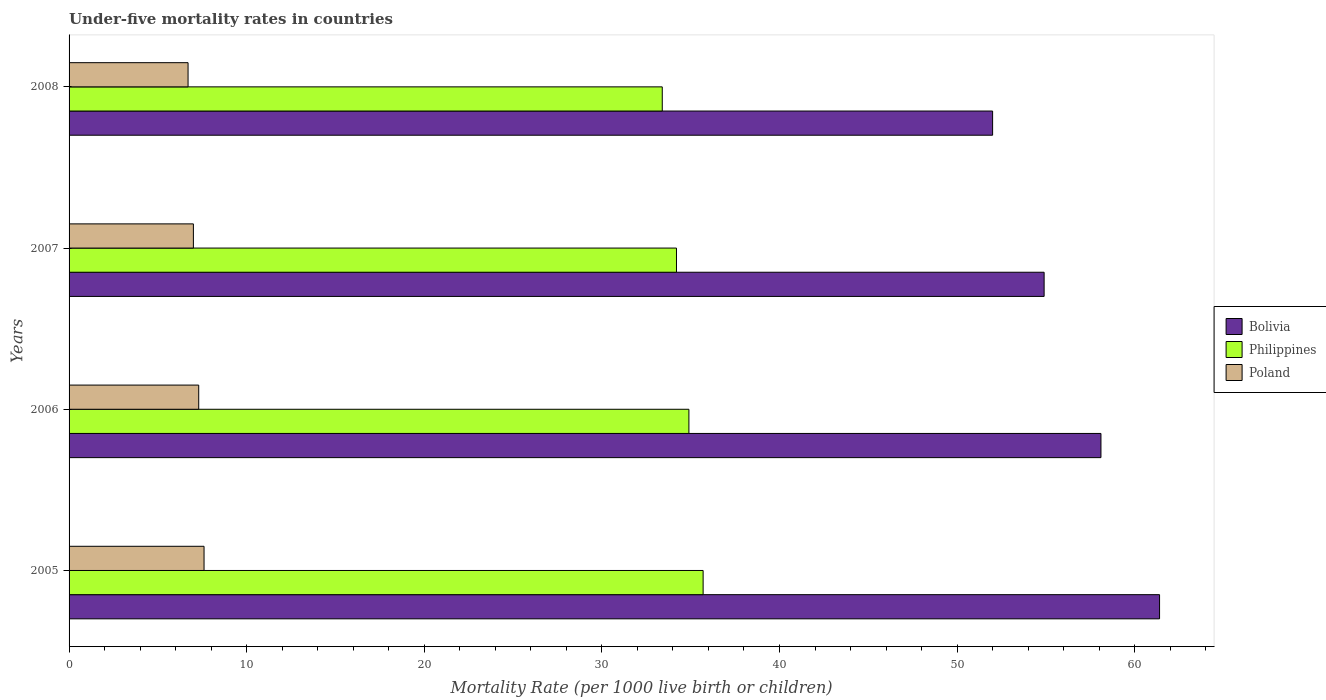In how many cases, is the number of bars for a given year not equal to the number of legend labels?
Keep it short and to the point. 0. Across all years, what is the maximum under-five mortality rate in Philippines?
Your answer should be compact. 35.7. Across all years, what is the minimum under-five mortality rate in Poland?
Your answer should be compact. 6.7. What is the total under-five mortality rate in Philippines in the graph?
Provide a succinct answer. 138.2. What is the difference between the under-five mortality rate in Bolivia in 2005 and that in 2006?
Provide a short and direct response. 3.3. What is the difference between the under-five mortality rate in Bolivia in 2006 and the under-five mortality rate in Poland in 2005?
Keep it short and to the point. 50.5. What is the average under-five mortality rate in Poland per year?
Offer a terse response. 7.15. In the year 2005, what is the difference between the under-five mortality rate in Philippines and under-five mortality rate in Bolivia?
Give a very brief answer. -25.7. In how many years, is the under-five mortality rate in Bolivia greater than 54 ?
Your answer should be very brief. 3. What is the ratio of the under-five mortality rate in Bolivia in 2007 to that in 2008?
Offer a very short reply. 1.06. Is the under-five mortality rate in Philippines in 2005 less than that in 2006?
Offer a very short reply. No. What is the difference between the highest and the second highest under-five mortality rate in Philippines?
Keep it short and to the point. 0.8. What is the difference between the highest and the lowest under-five mortality rate in Bolivia?
Provide a succinct answer. 9.4. Is the sum of the under-five mortality rate in Philippines in 2007 and 2008 greater than the maximum under-five mortality rate in Bolivia across all years?
Ensure brevity in your answer.  Yes. What does the 2nd bar from the bottom in 2007 represents?
Your answer should be compact. Philippines. How many bars are there?
Offer a terse response. 12. Are all the bars in the graph horizontal?
Offer a very short reply. Yes. How many years are there in the graph?
Offer a terse response. 4. What is the difference between two consecutive major ticks on the X-axis?
Make the answer very short. 10. How are the legend labels stacked?
Provide a succinct answer. Vertical. What is the title of the graph?
Provide a short and direct response. Under-five mortality rates in countries. What is the label or title of the X-axis?
Offer a very short reply. Mortality Rate (per 1000 live birth or children). What is the label or title of the Y-axis?
Provide a succinct answer. Years. What is the Mortality Rate (per 1000 live birth or children) in Bolivia in 2005?
Ensure brevity in your answer.  61.4. What is the Mortality Rate (per 1000 live birth or children) of Philippines in 2005?
Make the answer very short. 35.7. What is the Mortality Rate (per 1000 live birth or children) in Bolivia in 2006?
Ensure brevity in your answer.  58.1. What is the Mortality Rate (per 1000 live birth or children) in Philippines in 2006?
Give a very brief answer. 34.9. What is the Mortality Rate (per 1000 live birth or children) of Poland in 2006?
Your answer should be compact. 7.3. What is the Mortality Rate (per 1000 live birth or children) in Bolivia in 2007?
Your answer should be compact. 54.9. What is the Mortality Rate (per 1000 live birth or children) in Philippines in 2007?
Make the answer very short. 34.2. What is the Mortality Rate (per 1000 live birth or children) in Poland in 2007?
Provide a short and direct response. 7. What is the Mortality Rate (per 1000 live birth or children) of Bolivia in 2008?
Ensure brevity in your answer.  52. What is the Mortality Rate (per 1000 live birth or children) of Philippines in 2008?
Ensure brevity in your answer.  33.4. What is the Mortality Rate (per 1000 live birth or children) of Poland in 2008?
Make the answer very short. 6.7. Across all years, what is the maximum Mortality Rate (per 1000 live birth or children) in Bolivia?
Offer a very short reply. 61.4. Across all years, what is the maximum Mortality Rate (per 1000 live birth or children) in Philippines?
Ensure brevity in your answer.  35.7. Across all years, what is the maximum Mortality Rate (per 1000 live birth or children) in Poland?
Offer a terse response. 7.6. Across all years, what is the minimum Mortality Rate (per 1000 live birth or children) of Philippines?
Provide a succinct answer. 33.4. Across all years, what is the minimum Mortality Rate (per 1000 live birth or children) of Poland?
Your answer should be compact. 6.7. What is the total Mortality Rate (per 1000 live birth or children) in Bolivia in the graph?
Offer a very short reply. 226.4. What is the total Mortality Rate (per 1000 live birth or children) in Philippines in the graph?
Your answer should be very brief. 138.2. What is the total Mortality Rate (per 1000 live birth or children) of Poland in the graph?
Keep it short and to the point. 28.6. What is the difference between the Mortality Rate (per 1000 live birth or children) of Bolivia in 2005 and that in 2006?
Offer a very short reply. 3.3. What is the difference between the Mortality Rate (per 1000 live birth or children) of Philippines in 2005 and that in 2006?
Offer a very short reply. 0.8. What is the difference between the Mortality Rate (per 1000 live birth or children) of Bolivia in 2005 and that in 2007?
Provide a short and direct response. 6.5. What is the difference between the Mortality Rate (per 1000 live birth or children) of Bolivia in 2006 and that in 2007?
Offer a very short reply. 3.2. What is the difference between the Mortality Rate (per 1000 live birth or children) in Poland in 2006 and that in 2007?
Offer a very short reply. 0.3. What is the difference between the Mortality Rate (per 1000 live birth or children) of Bolivia in 2006 and that in 2008?
Your answer should be very brief. 6.1. What is the difference between the Mortality Rate (per 1000 live birth or children) of Philippines in 2007 and that in 2008?
Your answer should be compact. 0.8. What is the difference between the Mortality Rate (per 1000 live birth or children) in Bolivia in 2005 and the Mortality Rate (per 1000 live birth or children) in Poland in 2006?
Provide a succinct answer. 54.1. What is the difference between the Mortality Rate (per 1000 live birth or children) of Philippines in 2005 and the Mortality Rate (per 1000 live birth or children) of Poland in 2006?
Provide a succinct answer. 28.4. What is the difference between the Mortality Rate (per 1000 live birth or children) in Bolivia in 2005 and the Mortality Rate (per 1000 live birth or children) in Philippines in 2007?
Ensure brevity in your answer.  27.2. What is the difference between the Mortality Rate (per 1000 live birth or children) of Bolivia in 2005 and the Mortality Rate (per 1000 live birth or children) of Poland in 2007?
Provide a succinct answer. 54.4. What is the difference between the Mortality Rate (per 1000 live birth or children) of Philippines in 2005 and the Mortality Rate (per 1000 live birth or children) of Poland in 2007?
Provide a succinct answer. 28.7. What is the difference between the Mortality Rate (per 1000 live birth or children) in Bolivia in 2005 and the Mortality Rate (per 1000 live birth or children) in Philippines in 2008?
Make the answer very short. 28. What is the difference between the Mortality Rate (per 1000 live birth or children) in Bolivia in 2005 and the Mortality Rate (per 1000 live birth or children) in Poland in 2008?
Ensure brevity in your answer.  54.7. What is the difference between the Mortality Rate (per 1000 live birth or children) in Bolivia in 2006 and the Mortality Rate (per 1000 live birth or children) in Philippines in 2007?
Give a very brief answer. 23.9. What is the difference between the Mortality Rate (per 1000 live birth or children) in Bolivia in 2006 and the Mortality Rate (per 1000 live birth or children) in Poland in 2007?
Your answer should be very brief. 51.1. What is the difference between the Mortality Rate (per 1000 live birth or children) of Philippines in 2006 and the Mortality Rate (per 1000 live birth or children) of Poland in 2007?
Provide a short and direct response. 27.9. What is the difference between the Mortality Rate (per 1000 live birth or children) of Bolivia in 2006 and the Mortality Rate (per 1000 live birth or children) of Philippines in 2008?
Ensure brevity in your answer.  24.7. What is the difference between the Mortality Rate (per 1000 live birth or children) in Bolivia in 2006 and the Mortality Rate (per 1000 live birth or children) in Poland in 2008?
Ensure brevity in your answer.  51.4. What is the difference between the Mortality Rate (per 1000 live birth or children) in Philippines in 2006 and the Mortality Rate (per 1000 live birth or children) in Poland in 2008?
Offer a very short reply. 28.2. What is the difference between the Mortality Rate (per 1000 live birth or children) of Bolivia in 2007 and the Mortality Rate (per 1000 live birth or children) of Poland in 2008?
Provide a short and direct response. 48.2. What is the difference between the Mortality Rate (per 1000 live birth or children) of Philippines in 2007 and the Mortality Rate (per 1000 live birth or children) of Poland in 2008?
Offer a very short reply. 27.5. What is the average Mortality Rate (per 1000 live birth or children) of Bolivia per year?
Your answer should be very brief. 56.6. What is the average Mortality Rate (per 1000 live birth or children) of Philippines per year?
Your answer should be compact. 34.55. What is the average Mortality Rate (per 1000 live birth or children) of Poland per year?
Ensure brevity in your answer.  7.15. In the year 2005, what is the difference between the Mortality Rate (per 1000 live birth or children) of Bolivia and Mortality Rate (per 1000 live birth or children) of Philippines?
Offer a very short reply. 25.7. In the year 2005, what is the difference between the Mortality Rate (per 1000 live birth or children) in Bolivia and Mortality Rate (per 1000 live birth or children) in Poland?
Keep it short and to the point. 53.8. In the year 2005, what is the difference between the Mortality Rate (per 1000 live birth or children) in Philippines and Mortality Rate (per 1000 live birth or children) in Poland?
Ensure brevity in your answer.  28.1. In the year 2006, what is the difference between the Mortality Rate (per 1000 live birth or children) in Bolivia and Mortality Rate (per 1000 live birth or children) in Philippines?
Your response must be concise. 23.2. In the year 2006, what is the difference between the Mortality Rate (per 1000 live birth or children) of Bolivia and Mortality Rate (per 1000 live birth or children) of Poland?
Your answer should be very brief. 50.8. In the year 2006, what is the difference between the Mortality Rate (per 1000 live birth or children) of Philippines and Mortality Rate (per 1000 live birth or children) of Poland?
Provide a short and direct response. 27.6. In the year 2007, what is the difference between the Mortality Rate (per 1000 live birth or children) in Bolivia and Mortality Rate (per 1000 live birth or children) in Philippines?
Provide a succinct answer. 20.7. In the year 2007, what is the difference between the Mortality Rate (per 1000 live birth or children) of Bolivia and Mortality Rate (per 1000 live birth or children) of Poland?
Ensure brevity in your answer.  47.9. In the year 2007, what is the difference between the Mortality Rate (per 1000 live birth or children) in Philippines and Mortality Rate (per 1000 live birth or children) in Poland?
Make the answer very short. 27.2. In the year 2008, what is the difference between the Mortality Rate (per 1000 live birth or children) in Bolivia and Mortality Rate (per 1000 live birth or children) in Philippines?
Ensure brevity in your answer.  18.6. In the year 2008, what is the difference between the Mortality Rate (per 1000 live birth or children) in Bolivia and Mortality Rate (per 1000 live birth or children) in Poland?
Ensure brevity in your answer.  45.3. In the year 2008, what is the difference between the Mortality Rate (per 1000 live birth or children) of Philippines and Mortality Rate (per 1000 live birth or children) of Poland?
Your response must be concise. 26.7. What is the ratio of the Mortality Rate (per 1000 live birth or children) of Bolivia in 2005 to that in 2006?
Ensure brevity in your answer.  1.06. What is the ratio of the Mortality Rate (per 1000 live birth or children) of Philippines in 2005 to that in 2006?
Your response must be concise. 1.02. What is the ratio of the Mortality Rate (per 1000 live birth or children) of Poland in 2005 to that in 2006?
Keep it short and to the point. 1.04. What is the ratio of the Mortality Rate (per 1000 live birth or children) in Bolivia in 2005 to that in 2007?
Your answer should be very brief. 1.12. What is the ratio of the Mortality Rate (per 1000 live birth or children) of Philippines in 2005 to that in 2007?
Offer a very short reply. 1.04. What is the ratio of the Mortality Rate (per 1000 live birth or children) in Poland in 2005 to that in 2007?
Your answer should be very brief. 1.09. What is the ratio of the Mortality Rate (per 1000 live birth or children) in Bolivia in 2005 to that in 2008?
Make the answer very short. 1.18. What is the ratio of the Mortality Rate (per 1000 live birth or children) of Philippines in 2005 to that in 2008?
Offer a terse response. 1.07. What is the ratio of the Mortality Rate (per 1000 live birth or children) in Poland in 2005 to that in 2008?
Your answer should be compact. 1.13. What is the ratio of the Mortality Rate (per 1000 live birth or children) in Bolivia in 2006 to that in 2007?
Your answer should be very brief. 1.06. What is the ratio of the Mortality Rate (per 1000 live birth or children) of Philippines in 2006 to that in 2007?
Keep it short and to the point. 1.02. What is the ratio of the Mortality Rate (per 1000 live birth or children) in Poland in 2006 to that in 2007?
Ensure brevity in your answer.  1.04. What is the ratio of the Mortality Rate (per 1000 live birth or children) of Bolivia in 2006 to that in 2008?
Give a very brief answer. 1.12. What is the ratio of the Mortality Rate (per 1000 live birth or children) of Philippines in 2006 to that in 2008?
Give a very brief answer. 1.04. What is the ratio of the Mortality Rate (per 1000 live birth or children) in Poland in 2006 to that in 2008?
Give a very brief answer. 1.09. What is the ratio of the Mortality Rate (per 1000 live birth or children) in Bolivia in 2007 to that in 2008?
Offer a terse response. 1.06. What is the ratio of the Mortality Rate (per 1000 live birth or children) in Philippines in 2007 to that in 2008?
Offer a very short reply. 1.02. What is the ratio of the Mortality Rate (per 1000 live birth or children) in Poland in 2007 to that in 2008?
Offer a very short reply. 1.04. What is the difference between the highest and the second highest Mortality Rate (per 1000 live birth or children) of Poland?
Offer a very short reply. 0.3. What is the difference between the highest and the lowest Mortality Rate (per 1000 live birth or children) in Philippines?
Offer a very short reply. 2.3. What is the difference between the highest and the lowest Mortality Rate (per 1000 live birth or children) of Poland?
Provide a succinct answer. 0.9. 